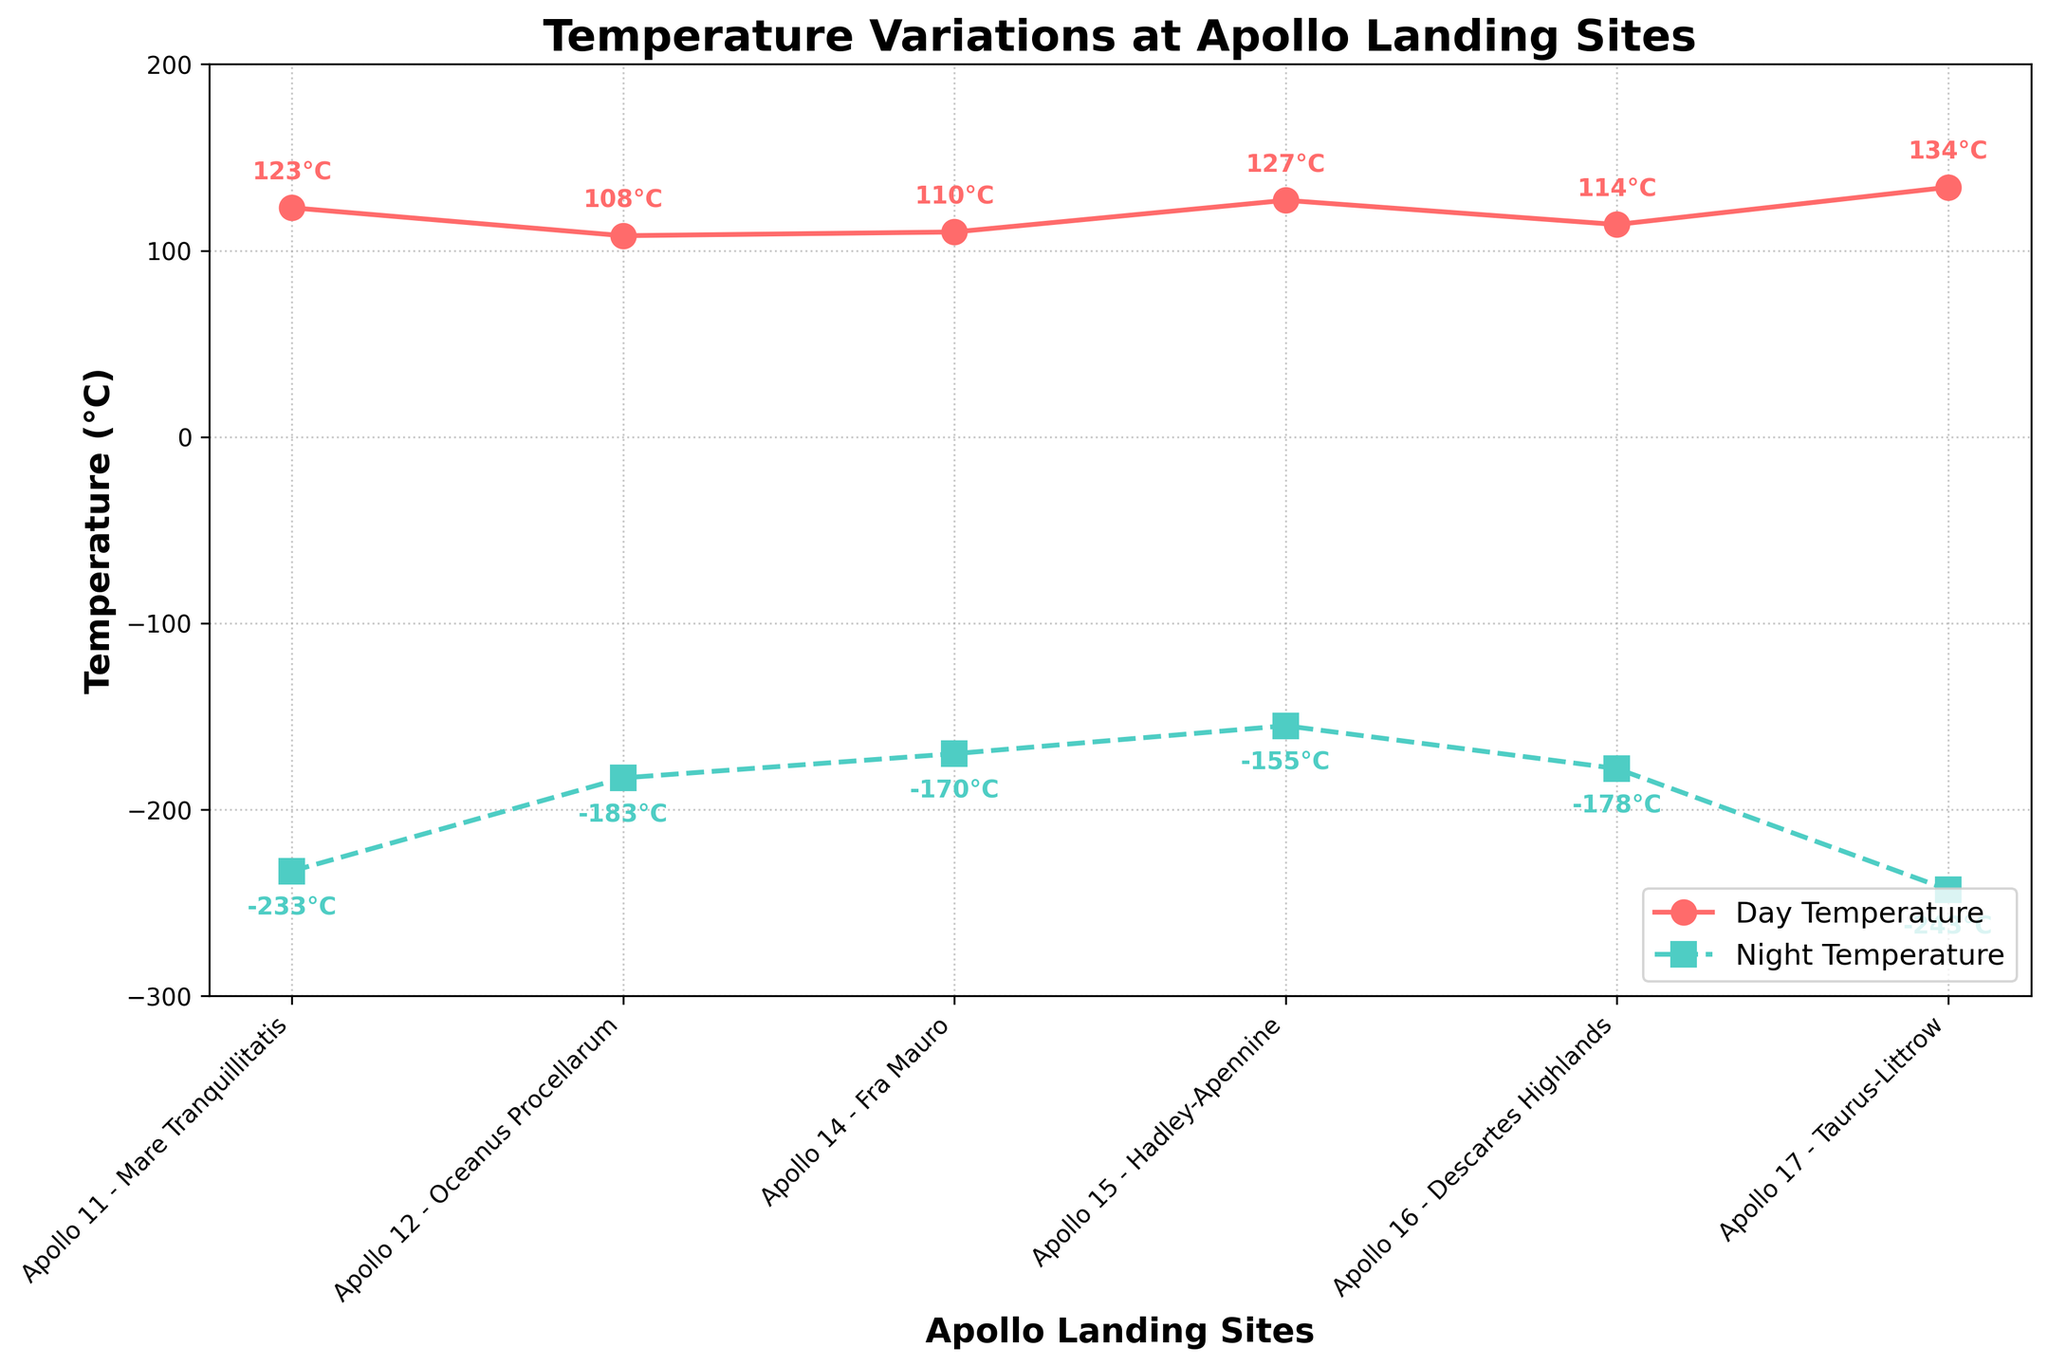What is the largest difference between day and night temperatures at any landing site? The largest difference can be calculated by comparing the differences at all sites: For Apollo 11 the difference is 123 - (-233) = 356°C, for Apollo 12 it is 108 - (-183) = 291°C, for Apollo 14 it is 110 - (-170) = 280°C, for Apollo 15 it is 127 - (-155) = 282°C, for Apollo 16 it is 114 - (-178) = 292°C, and for Apollo 17 it is 134 - (-243) = 377°C. The largest difference is 377°C at Apollo 17.
Answer: 377°C at Apollo 17 Which landing site had the highest recorded day temperature? By visually inspecting the plot, the highest day temperature among all landing sites is noted at Apollo 17 with a temperature of 134°C.
Answer: Apollo 17 How does the day temperature at Apollo 12 compare to Apollo 11? From the figure, Apollo 11's day temperature is 123°C while Apollo 12's day temperature is 108°C. Apollo 12 has a day temperature 15°C lower than Apollo 11.
Answer: Apollo 12 is 15°C lower What is the average day temperature of all the Apollo landing sites? The average can be calculated by summing all the day temperatures and dividing by the number of landing sites: (123 + 108 + 110 + 127 + 114 + 134)/6 = 716/6 ≈ 119.33°C.
Answer: 119.33°C Which site has the coldest night temperature? By inspecting the plot, the site with the coldest night temperature is Apollo 17 with a night temperature of -243°C.
Answer: Apollo 17 What is the temperature range between the highest and lowest night temperatures among the landing sites? The highest night temperature is -155°C (Apollo 15) and the lowest is -243°C (Apollo 17). The range is -155°C - (-243°C) = 88°C.
Answer: 88°C How many landing sites have night temperatures below -200°C? By checking each landing site on the plot, Apollo 11 (-233°C) and Apollo 17 (-243°C) have night temperatures below -200°C.
Answer: 2 sites What is the combined total of day and night temperatures for Apollo 16? The combined total is 114°C (day) + (-178°C) (night) = -64°C.
Answer: -64°C Which landing site has a smaller day-night temperature difference, Apollo 14 or Apollo 15? The difference for Apollo 14 is 110 - (-170) = 280°C and for Apollo 15 it is 127 - (-155) = 282°C. Apollo 14 has a smaller difference.
Answer: Apollo 14 Compare the night temperatures of Apollo 14 and Apollo 16 and state which is warmer. The night temperature for Apollo 14 is -170°C and for Apollo 16 it is -178°C. Apollo 14 is warmer by 8°C.
Answer: Apollo 14 is warmer by 8°C 